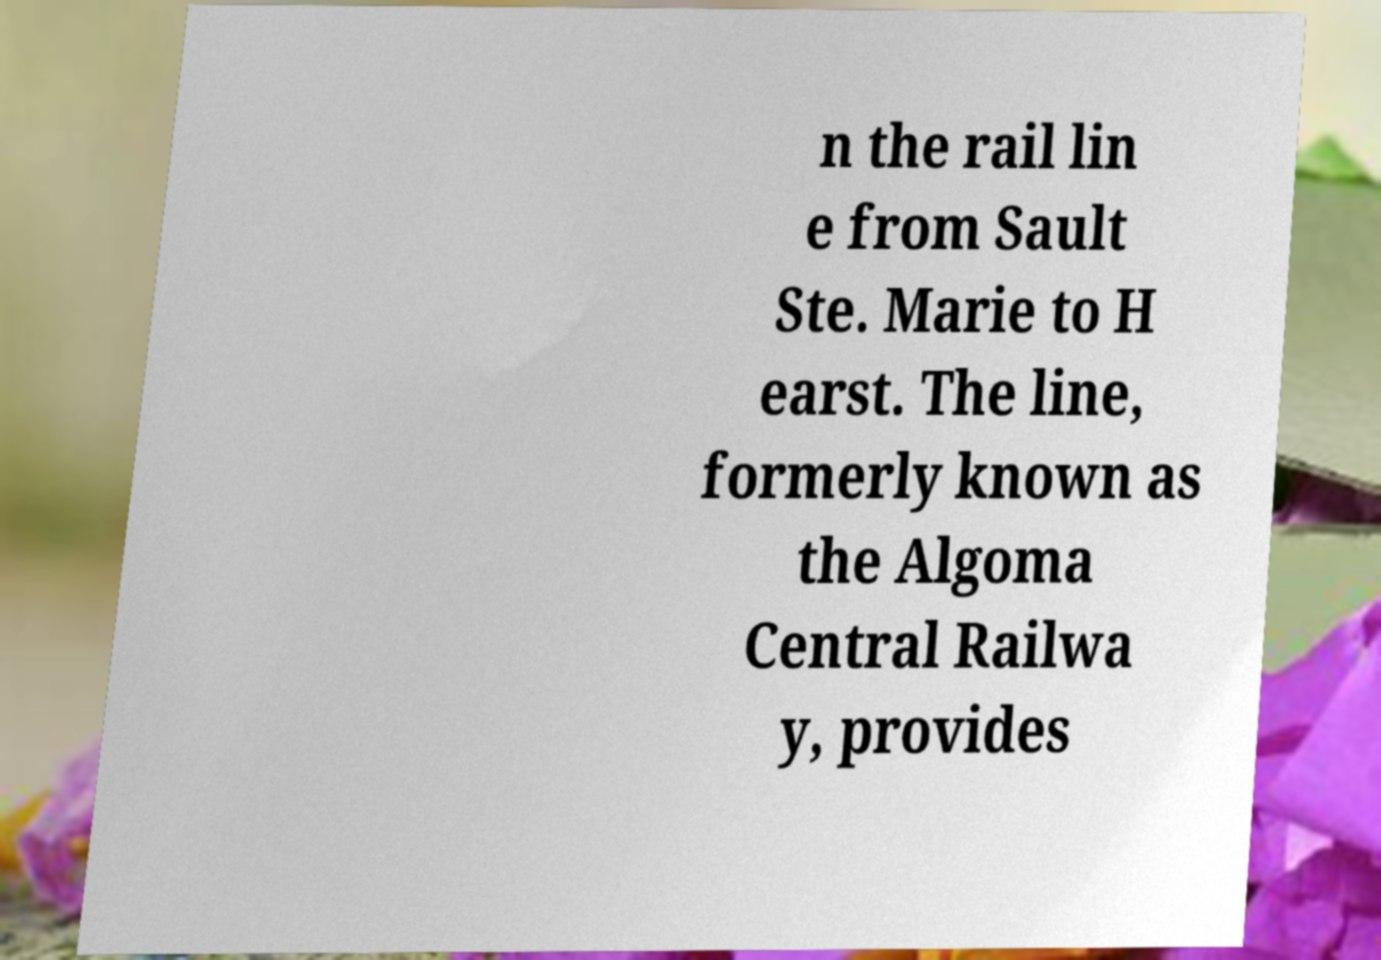Please identify and transcribe the text found in this image. n the rail lin e from Sault Ste. Marie to H earst. The line, formerly known as the Algoma Central Railwa y, provides 